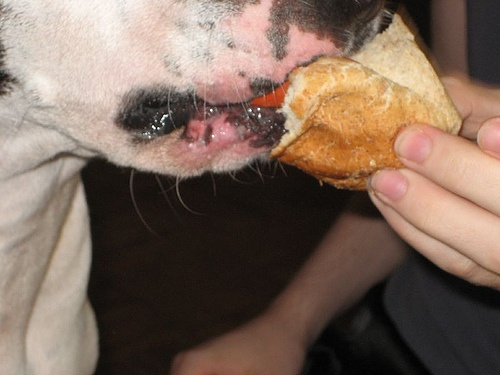Describe the objects in this image and their specific colors. I can see dog in darkgray, lightgray, tan, and gray tones, people in darkgray, black, tan, and brown tones, sandwich in darkgray, tan, and red tones, and carrot in darkgray, brown, maroon, and red tones in this image. 